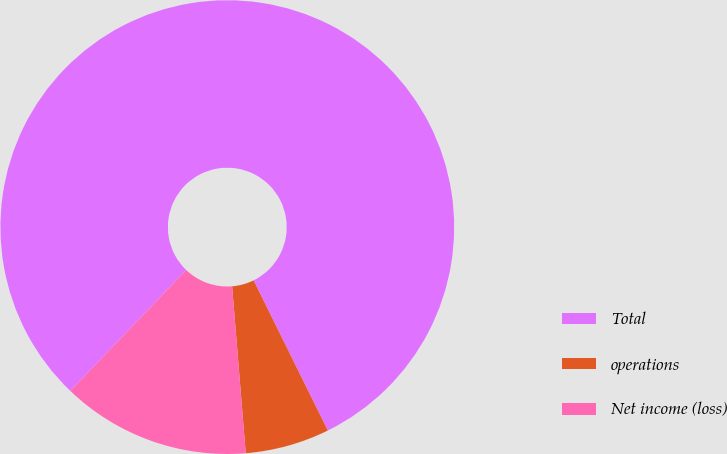Convert chart to OTSL. <chart><loc_0><loc_0><loc_500><loc_500><pie_chart><fcel>Total<fcel>operations<fcel>Net income (loss)<nl><fcel>80.53%<fcel>6.01%<fcel>13.46%<nl></chart> 